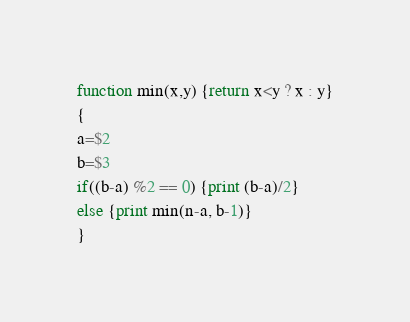<code> <loc_0><loc_0><loc_500><loc_500><_Awk_>function min(x,y) {return x<y ? x : y}
{
a=$2
b=$3
if((b-a) %2 == 0) {print (b-a)/2}
else {print min(n-a, b-1)}
}
</code> 